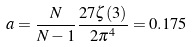Convert formula to latex. <formula><loc_0><loc_0><loc_500><loc_500>a = \frac { N } { N - 1 } \frac { 2 7 \zeta ( 3 ) } { 2 \pi ^ { 4 } } = 0 . 1 7 5</formula> 